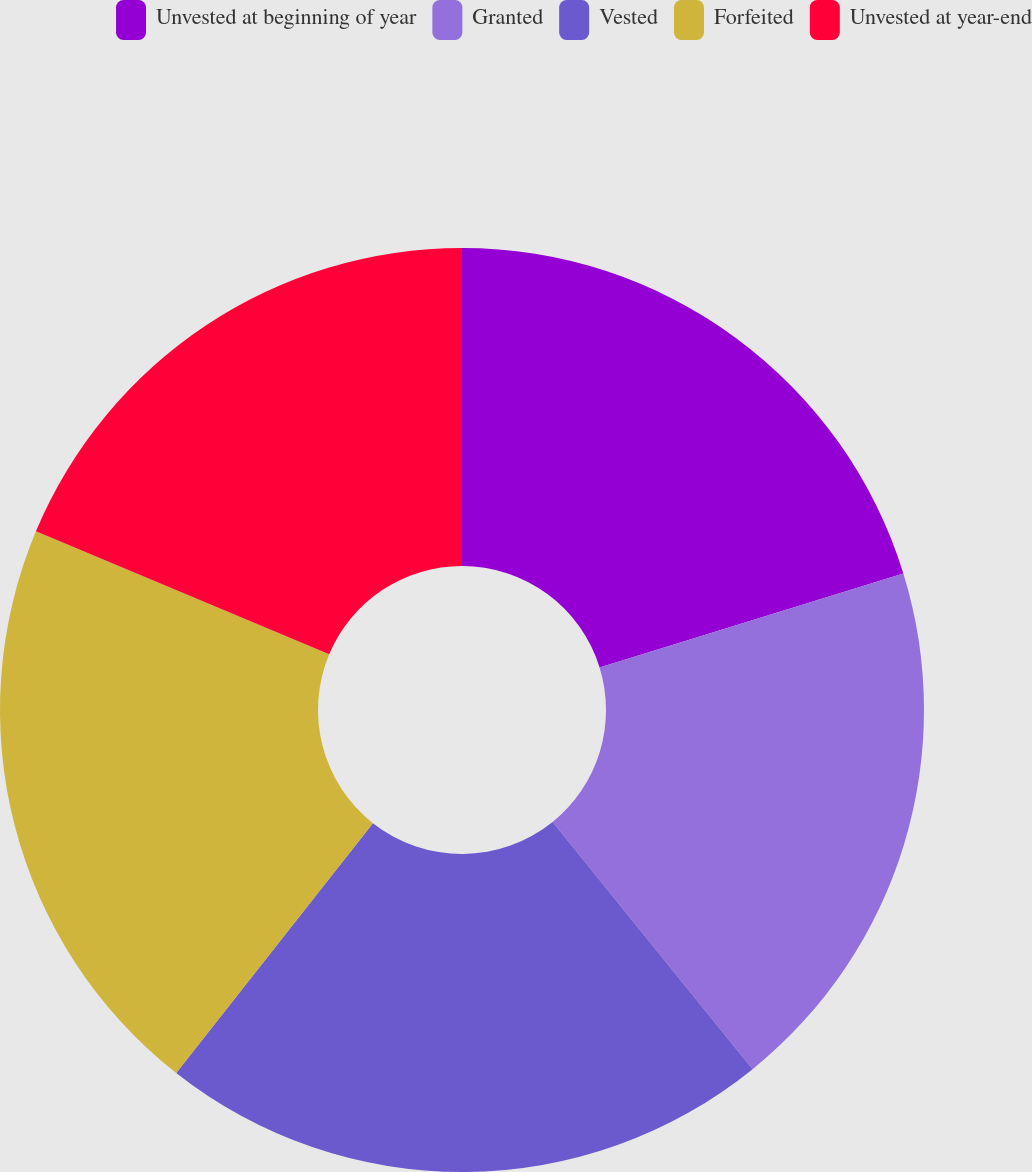Convert chart to OTSL. <chart><loc_0><loc_0><loc_500><loc_500><pie_chart><fcel>Unvested at beginning of year<fcel>Granted<fcel>Vested<fcel>Forfeited<fcel>Unvested at year-end<nl><fcel>20.22%<fcel>18.95%<fcel>21.44%<fcel>20.7%<fcel>18.68%<nl></chart> 